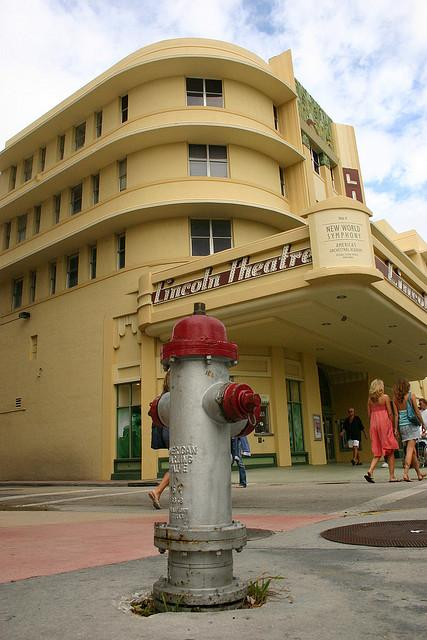What could someone do inside the yellow building? Please explain your reasoning. watch movie. The building is a theater. 